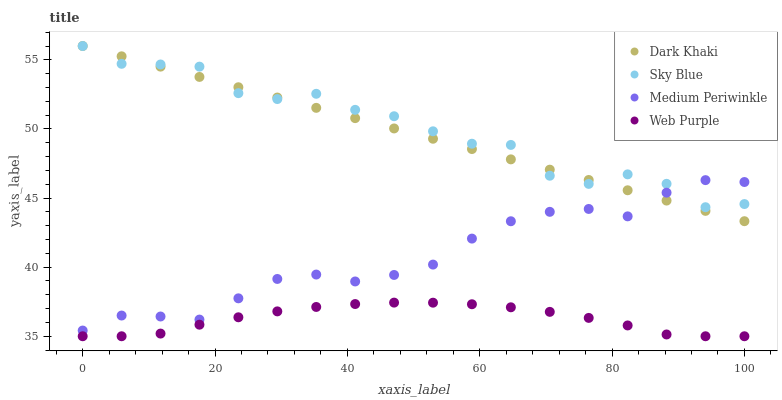Does Web Purple have the minimum area under the curve?
Answer yes or no. Yes. Does Sky Blue have the maximum area under the curve?
Answer yes or no. Yes. Does Sky Blue have the minimum area under the curve?
Answer yes or no. No. Does Web Purple have the maximum area under the curve?
Answer yes or no. No. Is Dark Khaki the smoothest?
Answer yes or no. Yes. Is Sky Blue the roughest?
Answer yes or no. Yes. Is Web Purple the smoothest?
Answer yes or no. No. Is Web Purple the roughest?
Answer yes or no. No. Does Web Purple have the lowest value?
Answer yes or no. Yes. Does Sky Blue have the lowest value?
Answer yes or no. No. Does Sky Blue have the highest value?
Answer yes or no. Yes. Does Web Purple have the highest value?
Answer yes or no. No. Is Web Purple less than Sky Blue?
Answer yes or no. Yes. Is Dark Khaki greater than Web Purple?
Answer yes or no. Yes. Does Medium Periwinkle intersect Dark Khaki?
Answer yes or no. Yes. Is Medium Periwinkle less than Dark Khaki?
Answer yes or no. No. Is Medium Periwinkle greater than Dark Khaki?
Answer yes or no. No. Does Web Purple intersect Sky Blue?
Answer yes or no. No. 